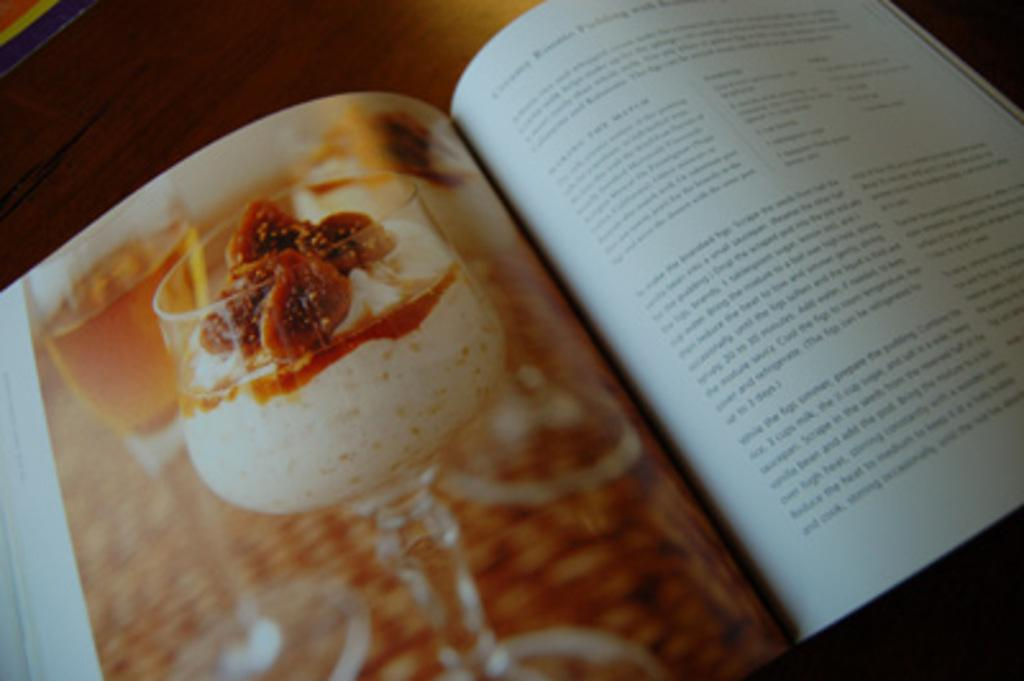What is placed on the wooden platform in the image? There is a book on a wooden platform in the image. What other items can be seen in the image besides the book? There are papers, glasses, and ice cream depicted on the papers in the image. What is written or drawn on the papers? There is some information on the papers. What type of music can be heard playing in the background of the image? There is no music or sound present in the image, so it cannot be determined what type of music might be playing. 